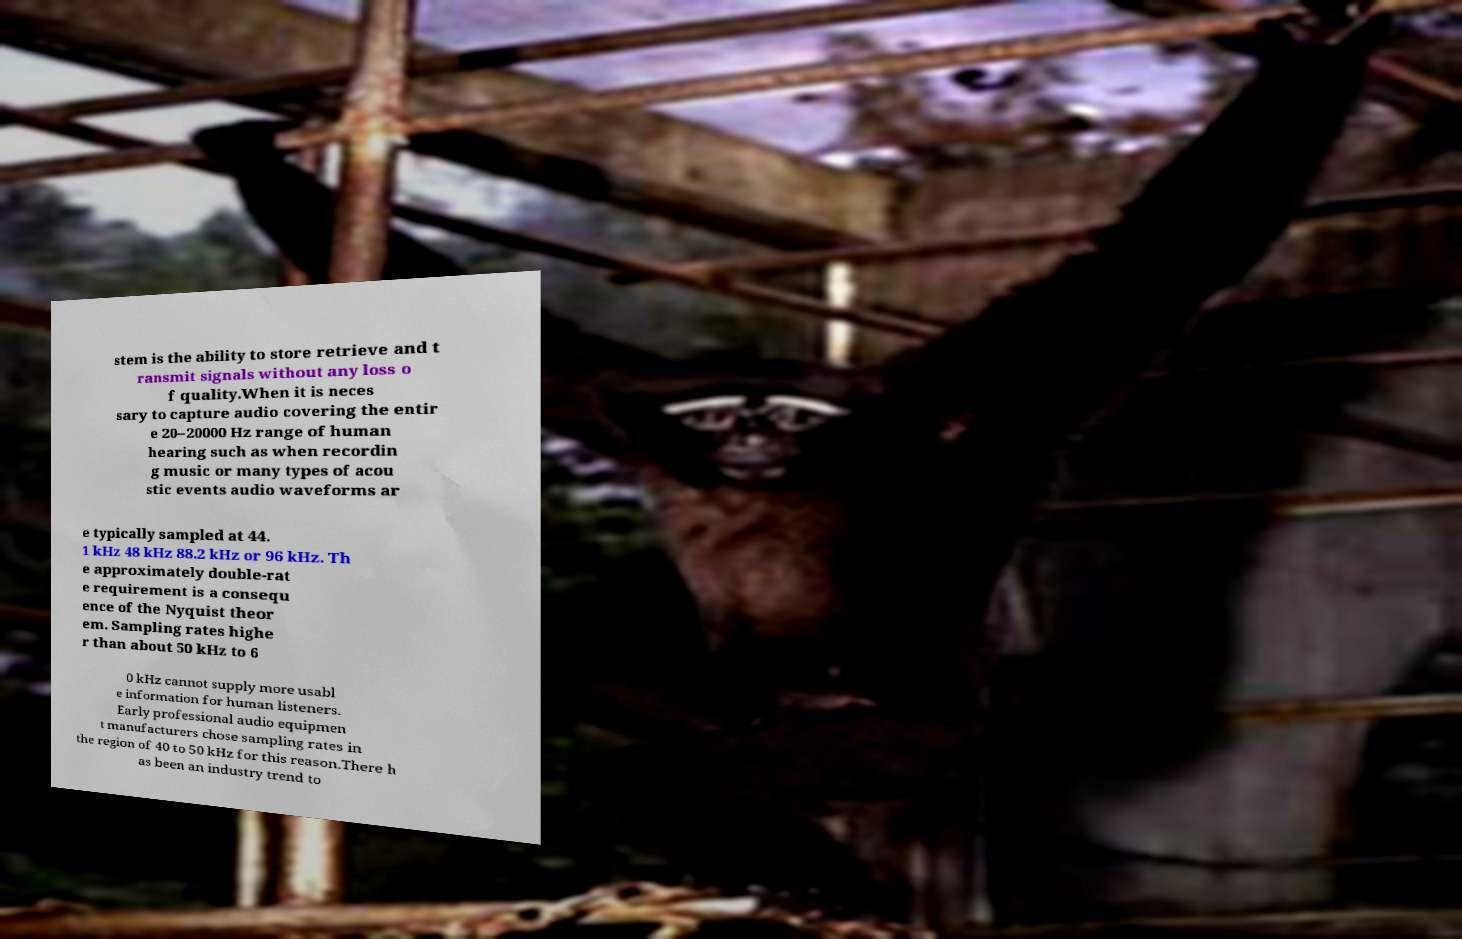I need the written content from this picture converted into text. Can you do that? stem is the ability to store retrieve and t ransmit signals without any loss o f quality.When it is neces sary to capture audio covering the entir e 20–20000 Hz range of human hearing such as when recordin g music or many types of acou stic events audio waveforms ar e typically sampled at 44. 1 kHz 48 kHz 88.2 kHz or 96 kHz. Th e approximately double-rat e requirement is a consequ ence of the Nyquist theor em. Sampling rates highe r than about 50 kHz to 6 0 kHz cannot supply more usabl e information for human listeners. Early professional audio equipmen t manufacturers chose sampling rates in the region of 40 to 50 kHz for this reason.There h as been an industry trend to 